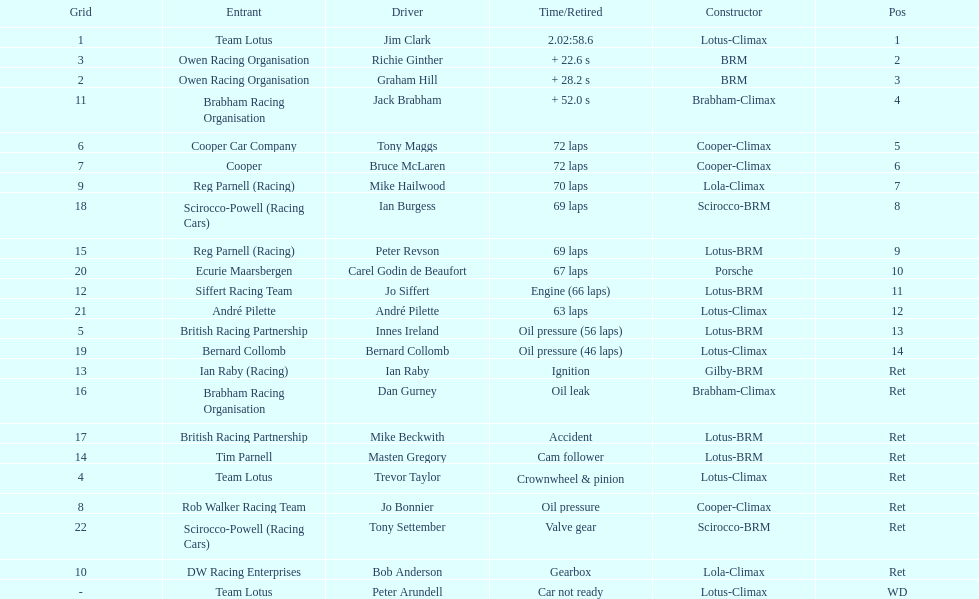Who came in first? Jim Clark. 